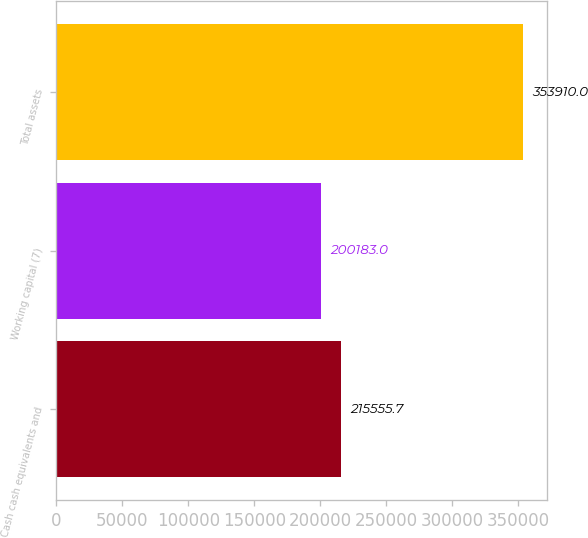Convert chart. <chart><loc_0><loc_0><loc_500><loc_500><bar_chart><fcel>Cash cash equivalents and<fcel>Working capital (7)<fcel>Total assets<nl><fcel>215556<fcel>200183<fcel>353910<nl></chart> 